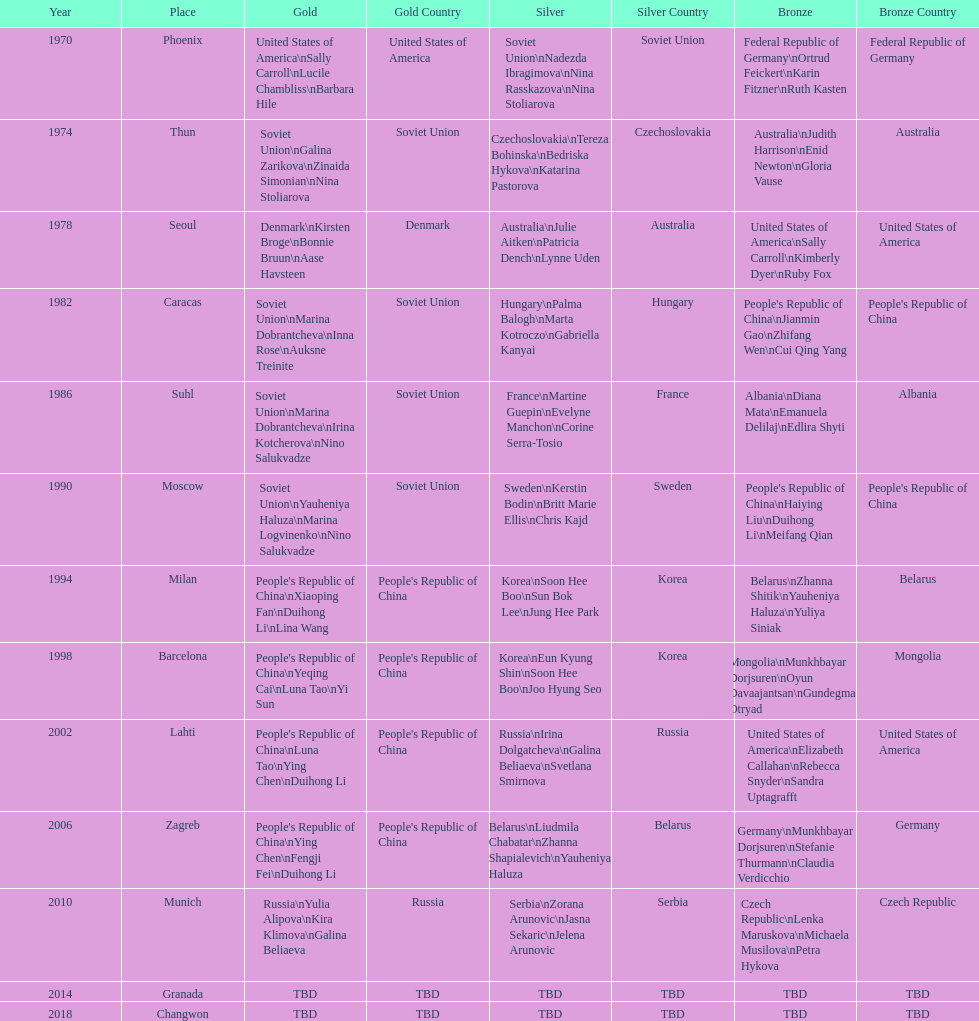What is the first place listed in this chart? Phoenix. 